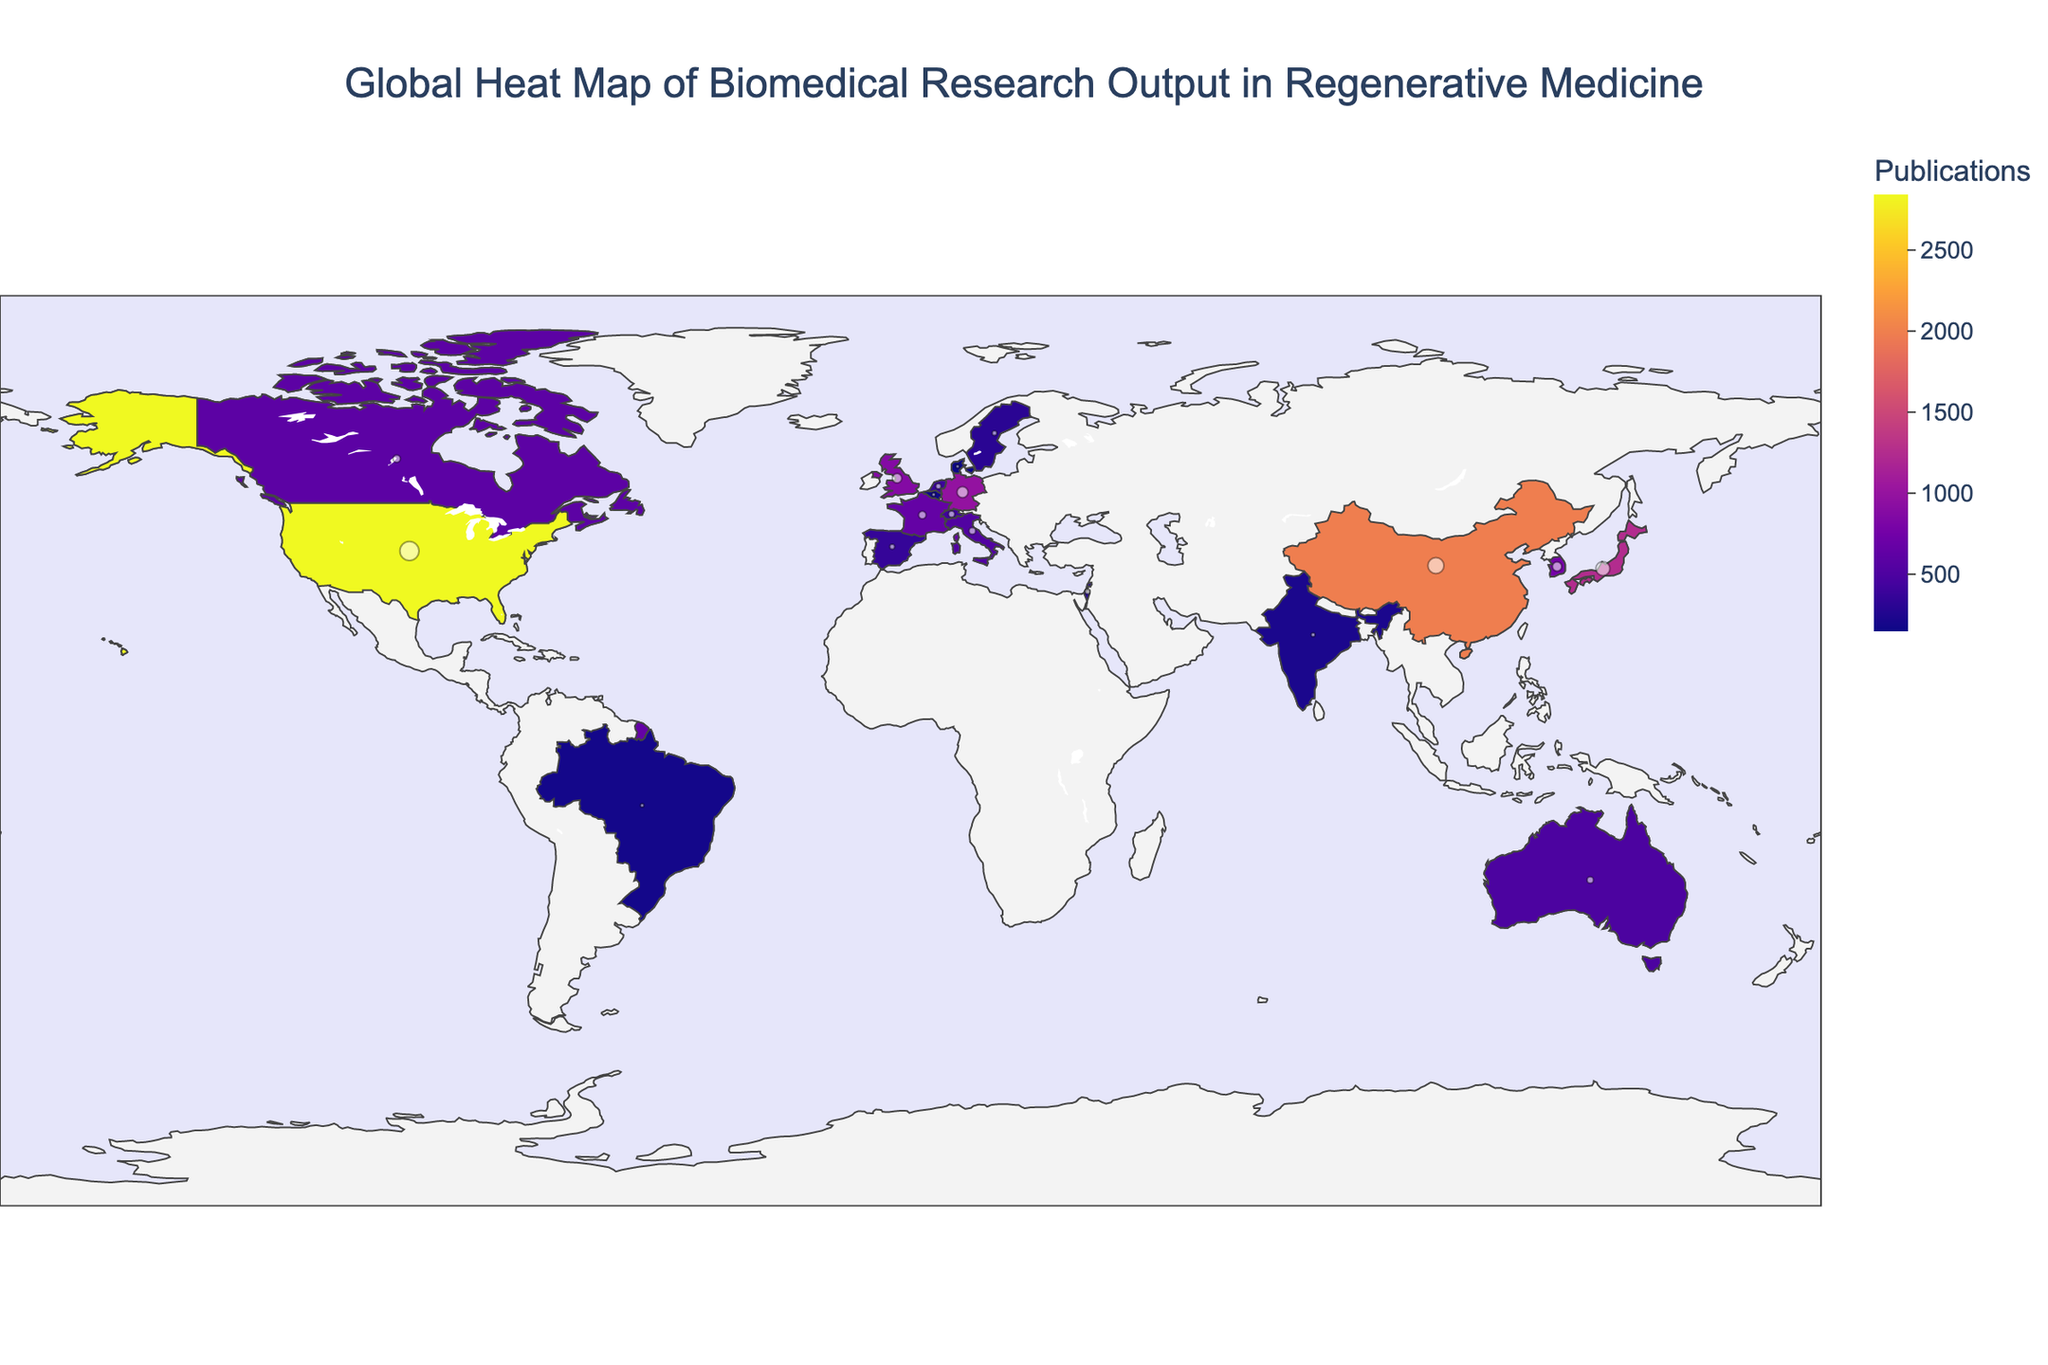Which country has the highest number of publications? The country with the highest number of publications can be identified by looking for the country with the most intense color on the choropleth map and the largest corresponding 'Publications' value in the hover data. The United States has a value of 2843.
Answer: United States Which country has the least number of patents? The country with the fewest patents is determined by finding the smallest 'Patents' value in the hover data. Denmark has the lowest value with 35 patents.
Answer: Denmark How many total publications are there in the top 5 countries? Sum the number of publications in the top 5 countries: United States (2843), China (1987), Japan (1245), Germany (982), and United Kingdom (876). 2843 + 1987 + 1245 + 982 + 876 = 7933.
Answer: 7933 Which country has more patents: France or Canada? Compare the 'Patents' value from the hover data of France and Canada. France has 201 patents while Canada has 187.
Answer: France Which country has the highest ratio of patents to publications? Calculate the ratio of patents to publications for each country and identify the maximum. The ratio in the United States is 1256/2843 = 0.44; in China, it's 892/1987 = 0.45; in Japan, it's 678/1245 = 0.54. Israel has a ratio of 92/276 = 0.33. The highest ratio is in Japan with 0.54.
Answer: Japan Which countries are in the top 10 for publications but not in the top 10 for patents? Identify countries in the top 10 for publications (by their values) and see if they are present in the top 10 for patents. The countries are: United Kingdom (876 publications, 312 patents), Germany (982 publications, 423 patents), France (654 publications, 201 patents). Germany and the United Kingdom are not listed in the top 10 for patents.
Answer: United Kingdom, Germany How does the publication output of South Korea compare to Japan? Compare the publication numbers from the hover data: South Korea has 765 publications and Japan has 1245 publications, so Japan has more publications than South Korea.
Answer: Japan What's the total number of patents for all countries combined? Sum the number of patents for each country: 1256 + 892 + 678 + 423 + 312 + 298 + 201 + 187 + 156 + 143 + 132 + 98 + 87 + 76 + 92 + 68 + 54 + 41 + 39 + 35 = 5260.
Answer: 5260 